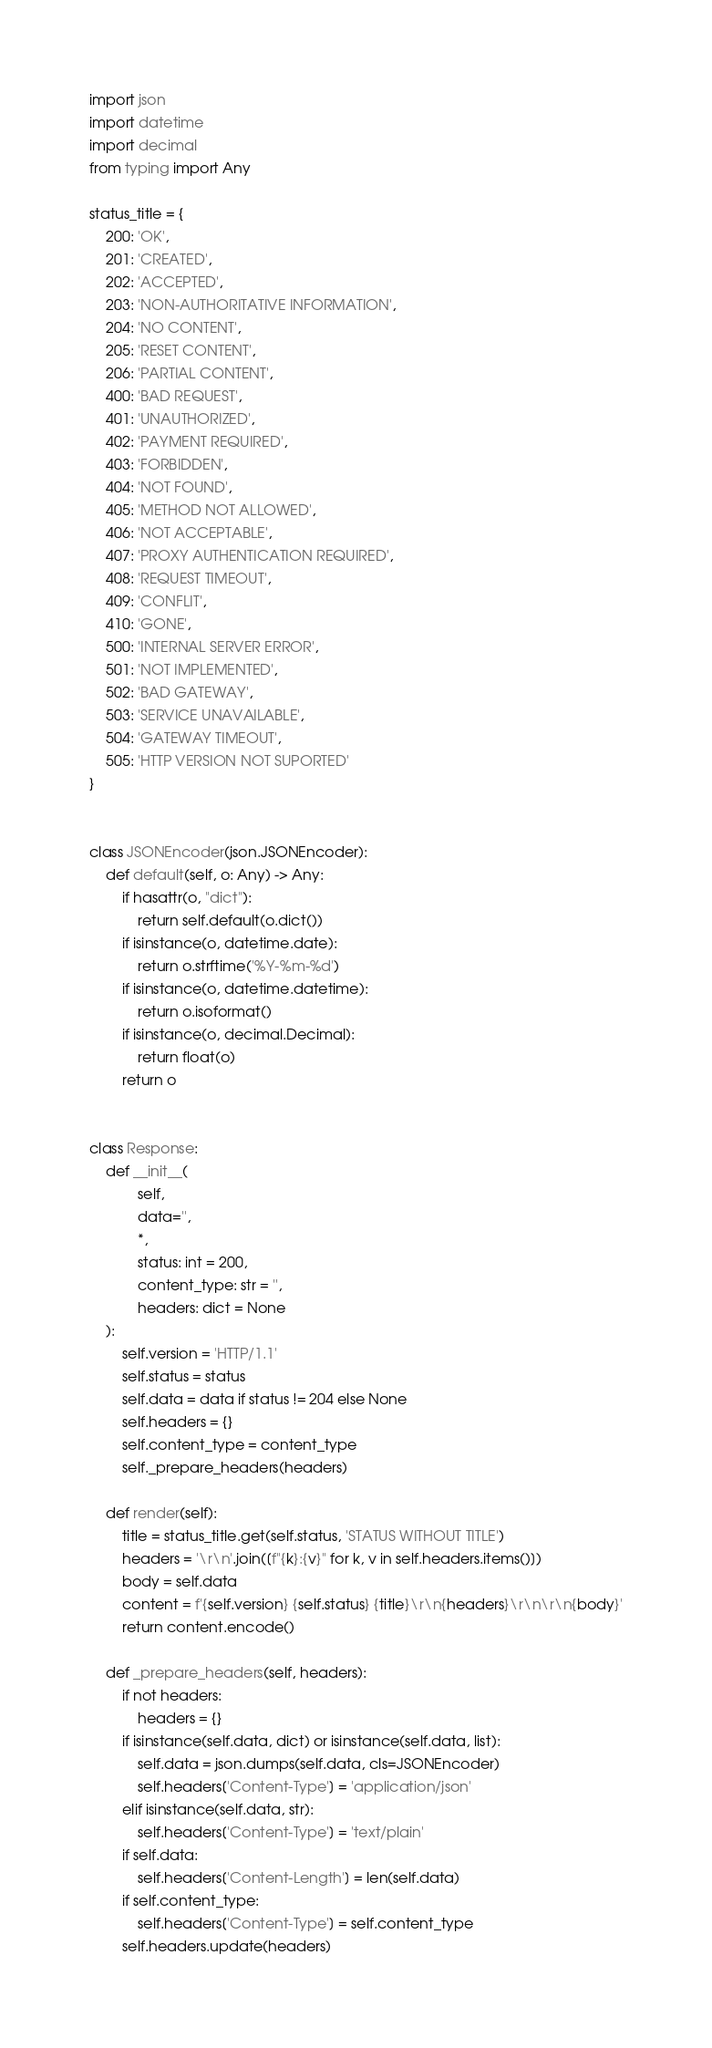<code> <loc_0><loc_0><loc_500><loc_500><_Python_>import json
import datetime
import decimal
from typing import Any

status_title = {
    200: 'OK',
    201: 'CREATED',
    202: 'ACCEPTED',
    203: 'NON-AUTHORITATIVE INFORMATION',
    204: 'NO CONTENT',
    205: 'RESET CONTENT',
    206: 'PARTIAL CONTENT',
    400: 'BAD REQUEST',
    401: 'UNAUTHORIZED',
    402: 'PAYMENT REQUIRED',
    403: 'FORBIDDEN',
    404: 'NOT FOUND',
    405: 'METHOD NOT ALLOWED',
    406: 'NOT ACCEPTABLE',
    407: 'PROXY AUTHENTICATION REQUIRED',
    408: 'REQUEST TIMEOUT',
    409: 'CONFLIT',
    410: 'GONE',
    500: 'INTERNAL SERVER ERROR',
    501: 'NOT IMPLEMENTED',
    502: 'BAD GATEWAY',
    503: 'SERVICE UNAVAILABLE',
    504: 'GATEWAY TIMEOUT',
    505: 'HTTP VERSION NOT SUPORTED'
}


class JSONEncoder(json.JSONEncoder):
    def default(self, o: Any) -> Any:
        if hasattr(o, "dict"):
            return self.default(o.dict())
        if isinstance(o, datetime.date):
            return o.strftime('%Y-%m-%d')
        if isinstance(o, datetime.datetime):
            return o.isoformat()
        if isinstance(o, decimal.Decimal):
            return float(o)
        return o


class Response:
    def __init__(
            self,
            data='',
            *,
            status: int = 200,
            content_type: str = '',
            headers: dict = None
    ):
        self.version = 'HTTP/1.1'
        self.status = status
        self.data = data if status != 204 else None
        self.headers = {}
        self.content_type = content_type
        self._prepare_headers(headers)

    def render(self):
        title = status_title.get(self.status, 'STATUS WITHOUT TITLE')
        headers = '\r\n'.join([f"{k}:{v}" for k, v in self.headers.items()])
        body = self.data
        content = f'{self.version} {self.status} {title}\r\n{headers}\r\n\r\n{body}'
        return content.encode()

    def _prepare_headers(self, headers):
        if not headers:
            headers = {}
        if isinstance(self.data, dict) or isinstance(self.data, list):
            self.data = json.dumps(self.data, cls=JSONEncoder)
            self.headers['Content-Type'] = 'application/json'
        elif isinstance(self.data, str):
            self.headers['Content-Type'] = 'text/plain'
        if self.data:
            self.headers['Content-Length'] = len(self.data)
        if self.content_type:
            self.headers['Content-Type'] = self.content_type
        self.headers.update(headers)
</code> 